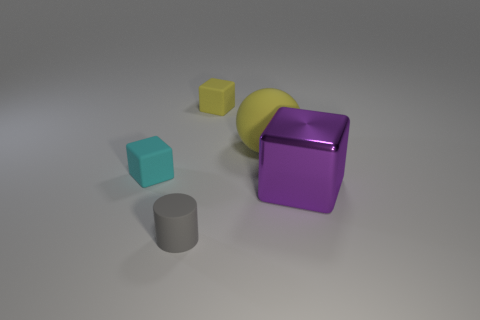Subtract all purple shiny cubes. How many cubes are left? 2 Add 4 tiny cyan rubber cubes. How many objects exist? 9 Add 1 small yellow rubber objects. How many small yellow rubber objects are left? 2 Add 4 matte balls. How many matte balls exist? 5 Subtract 0 brown cylinders. How many objects are left? 5 Subtract all balls. How many objects are left? 4 Subtract all big purple objects. Subtract all gray cylinders. How many objects are left? 3 